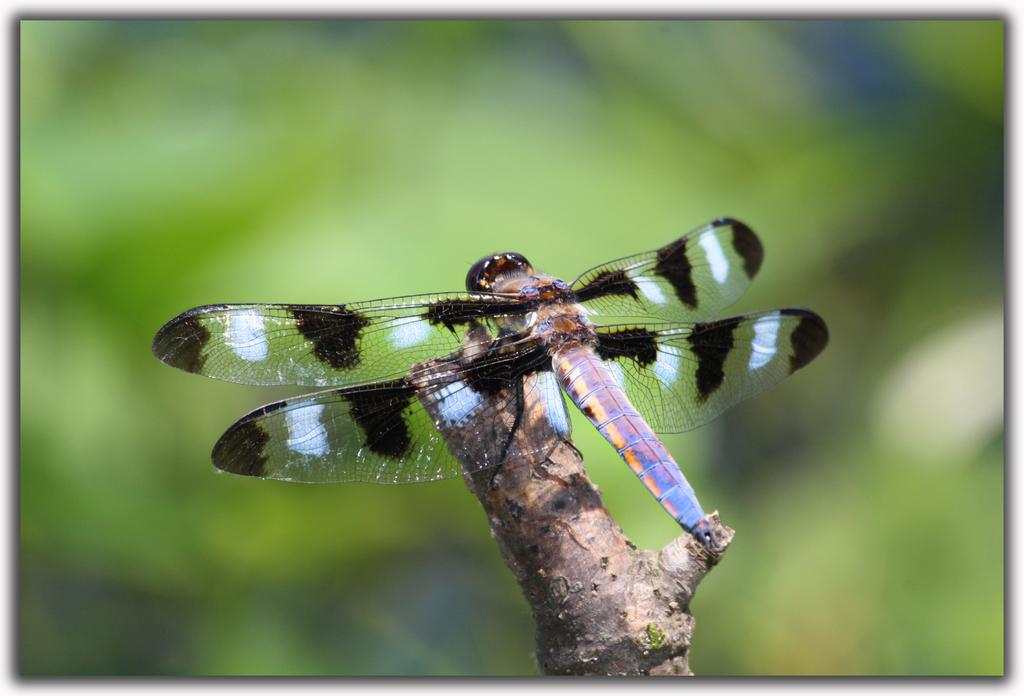What is present in the image that is not a part of the natural environment? There is a fly in the image. Where is the fly located in the image? The fly is on a branch. What type of hands can be seen holding the fly in the image? There are no hands present in the image, and the fly is not being held. What type of quiver is visible in the image? There is no quiver present in the image. 